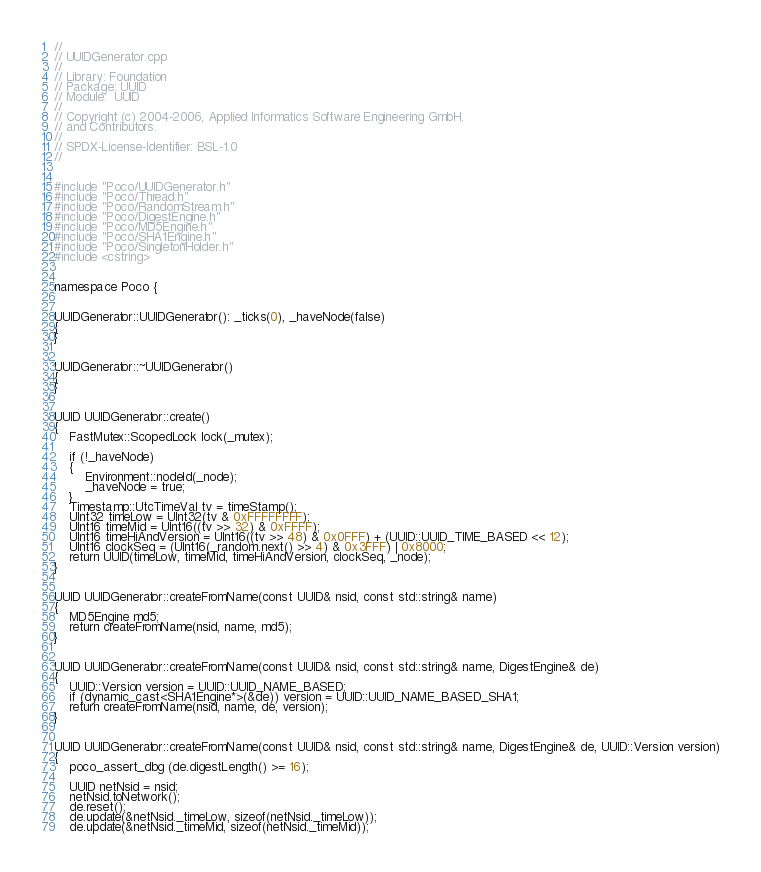<code> <loc_0><loc_0><loc_500><loc_500><_C++_>//
// UUIDGenerator.cpp
//
// Library: Foundation
// Package: UUID
// Module:  UUID
//
// Copyright (c) 2004-2006, Applied Informatics Software Engineering GmbH.
// and Contributors.
//
// SPDX-License-Identifier:	BSL-1.0
//


#include "Poco/UUIDGenerator.h"
#include "Poco/Thread.h"
#include "Poco/RandomStream.h"
#include "Poco/DigestEngine.h"
#include "Poco/MD5Engine.h"
#include "Poco/SHA1Engine.h"
#include "Poco/SingletonHolder.h"
#include <cstring>


namespace Poco {


UUIDGenerator::UUIDGenerator(): _ticks(0), _haveNode(false)
{
}


UUIDGenerator::~UUIDGenerator()
{
}


UUID UUIDGenerator::create()
{
	FastMutex::ScopedLock lock(_mutex);

	if (!_haveNode)
	{
		Environment::nodeId(_node);
		_haveNode = true;
	}
	Timestamp::UtcTimeVal tv = timeStamp();
	UInt32 timeLow = UInt32(tv & 0xFFFFFFFF);
	UInt16 timeMid = UInt16((tv >> 32) & 0xFFFF);
	UInt16 timeHiAndVersion = UInt16((tv >> 48) & 0x0FFF) + (UUID::UUID_TIME_BASED << 12);
	UInt16 clockSeq = (UInt16(_random.next() >> 4) & 0x3FFF) | 0x8000;
	return UUID(timeLow, timeMid, timeHiAndVersion, clockSeq, _node);
}


UUID UUIDGenerator::createFromName(const UUID& nsid, const std::string& name)
{
	MD5Engine md5;
	return createFromName(nsid, name, md5);
}


UUID UUIDGenerator::createFromName(const UUID& nsid, const std::string& name, DigestEngine& de)
{
	UUID::Version version = UUID::UUID_NAME_BASED;
	if (dynamic_cast<SHA1Engine*>(&de)) version = UUID::UUID_NAME_BASED_SHA1;
	return createFromName(nsid, name, de, version);
}


UUID UUIDGenerator::createFromName(const UUID& nsid, const std::string& name, DigestEngine& de, UUID::Version version)
{
	poco_assert_dbg (de.digestLength() >= 16);

	UUID netNsid = nsid;
	netNsid.toNetwork();
	de.reset();
	de.update(&netNsid._timeLow, sizeof(netNsid._timeLow));
	de.update(&netNsid._timeMid, sizeof(netNsid._timeMid));</code> 